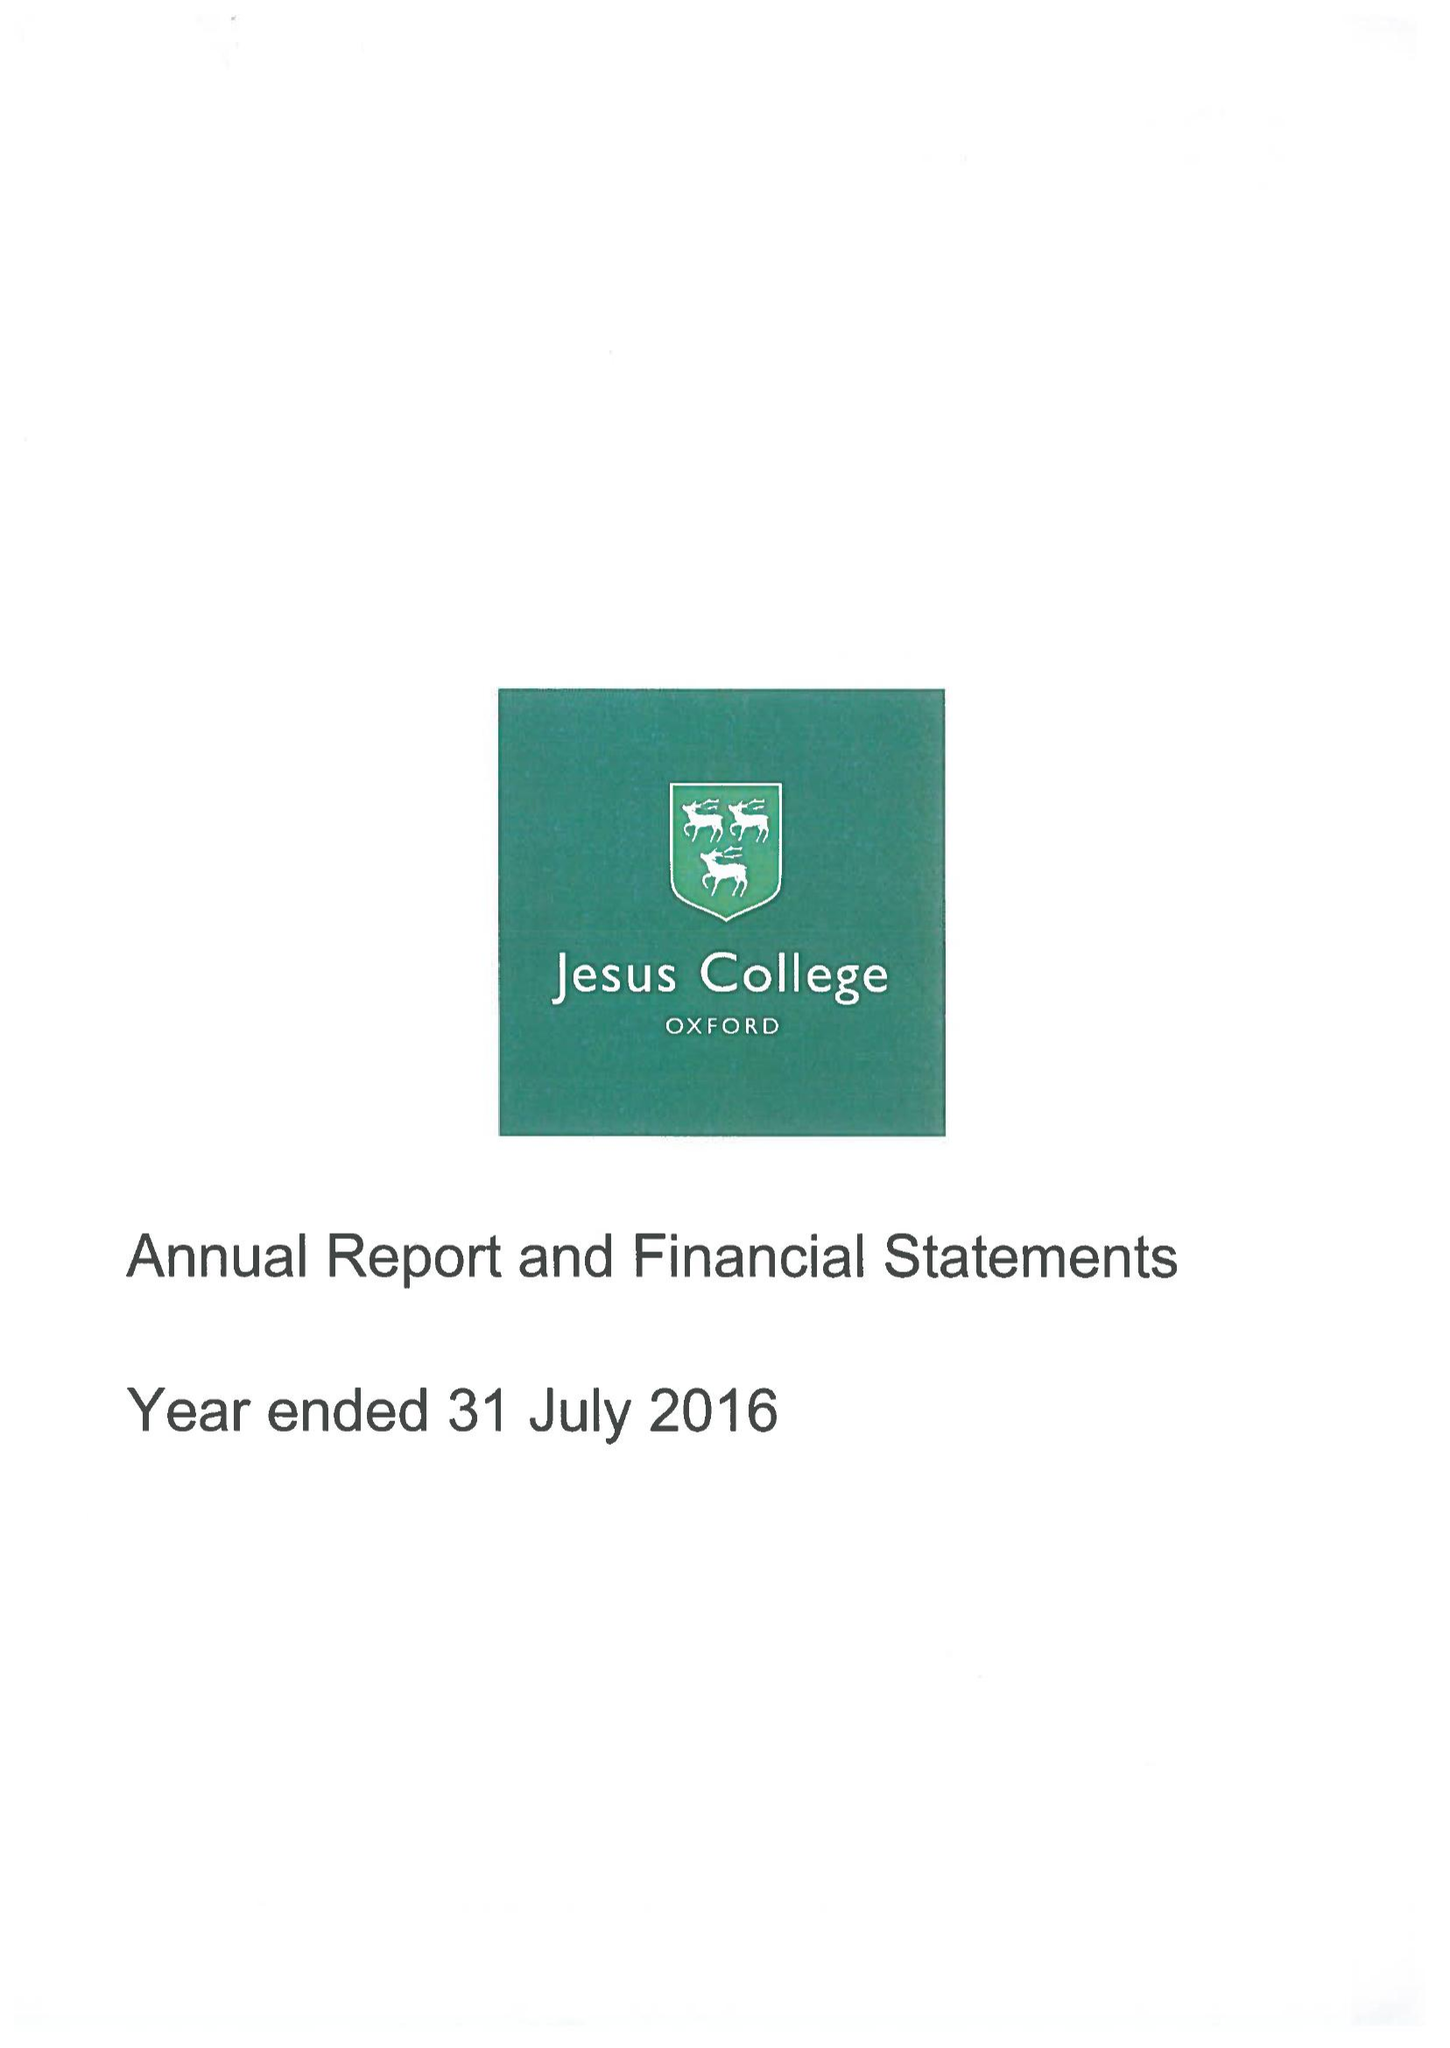What is the value for the charity_number?
Answer the question using a single word or phrase. 1137435 